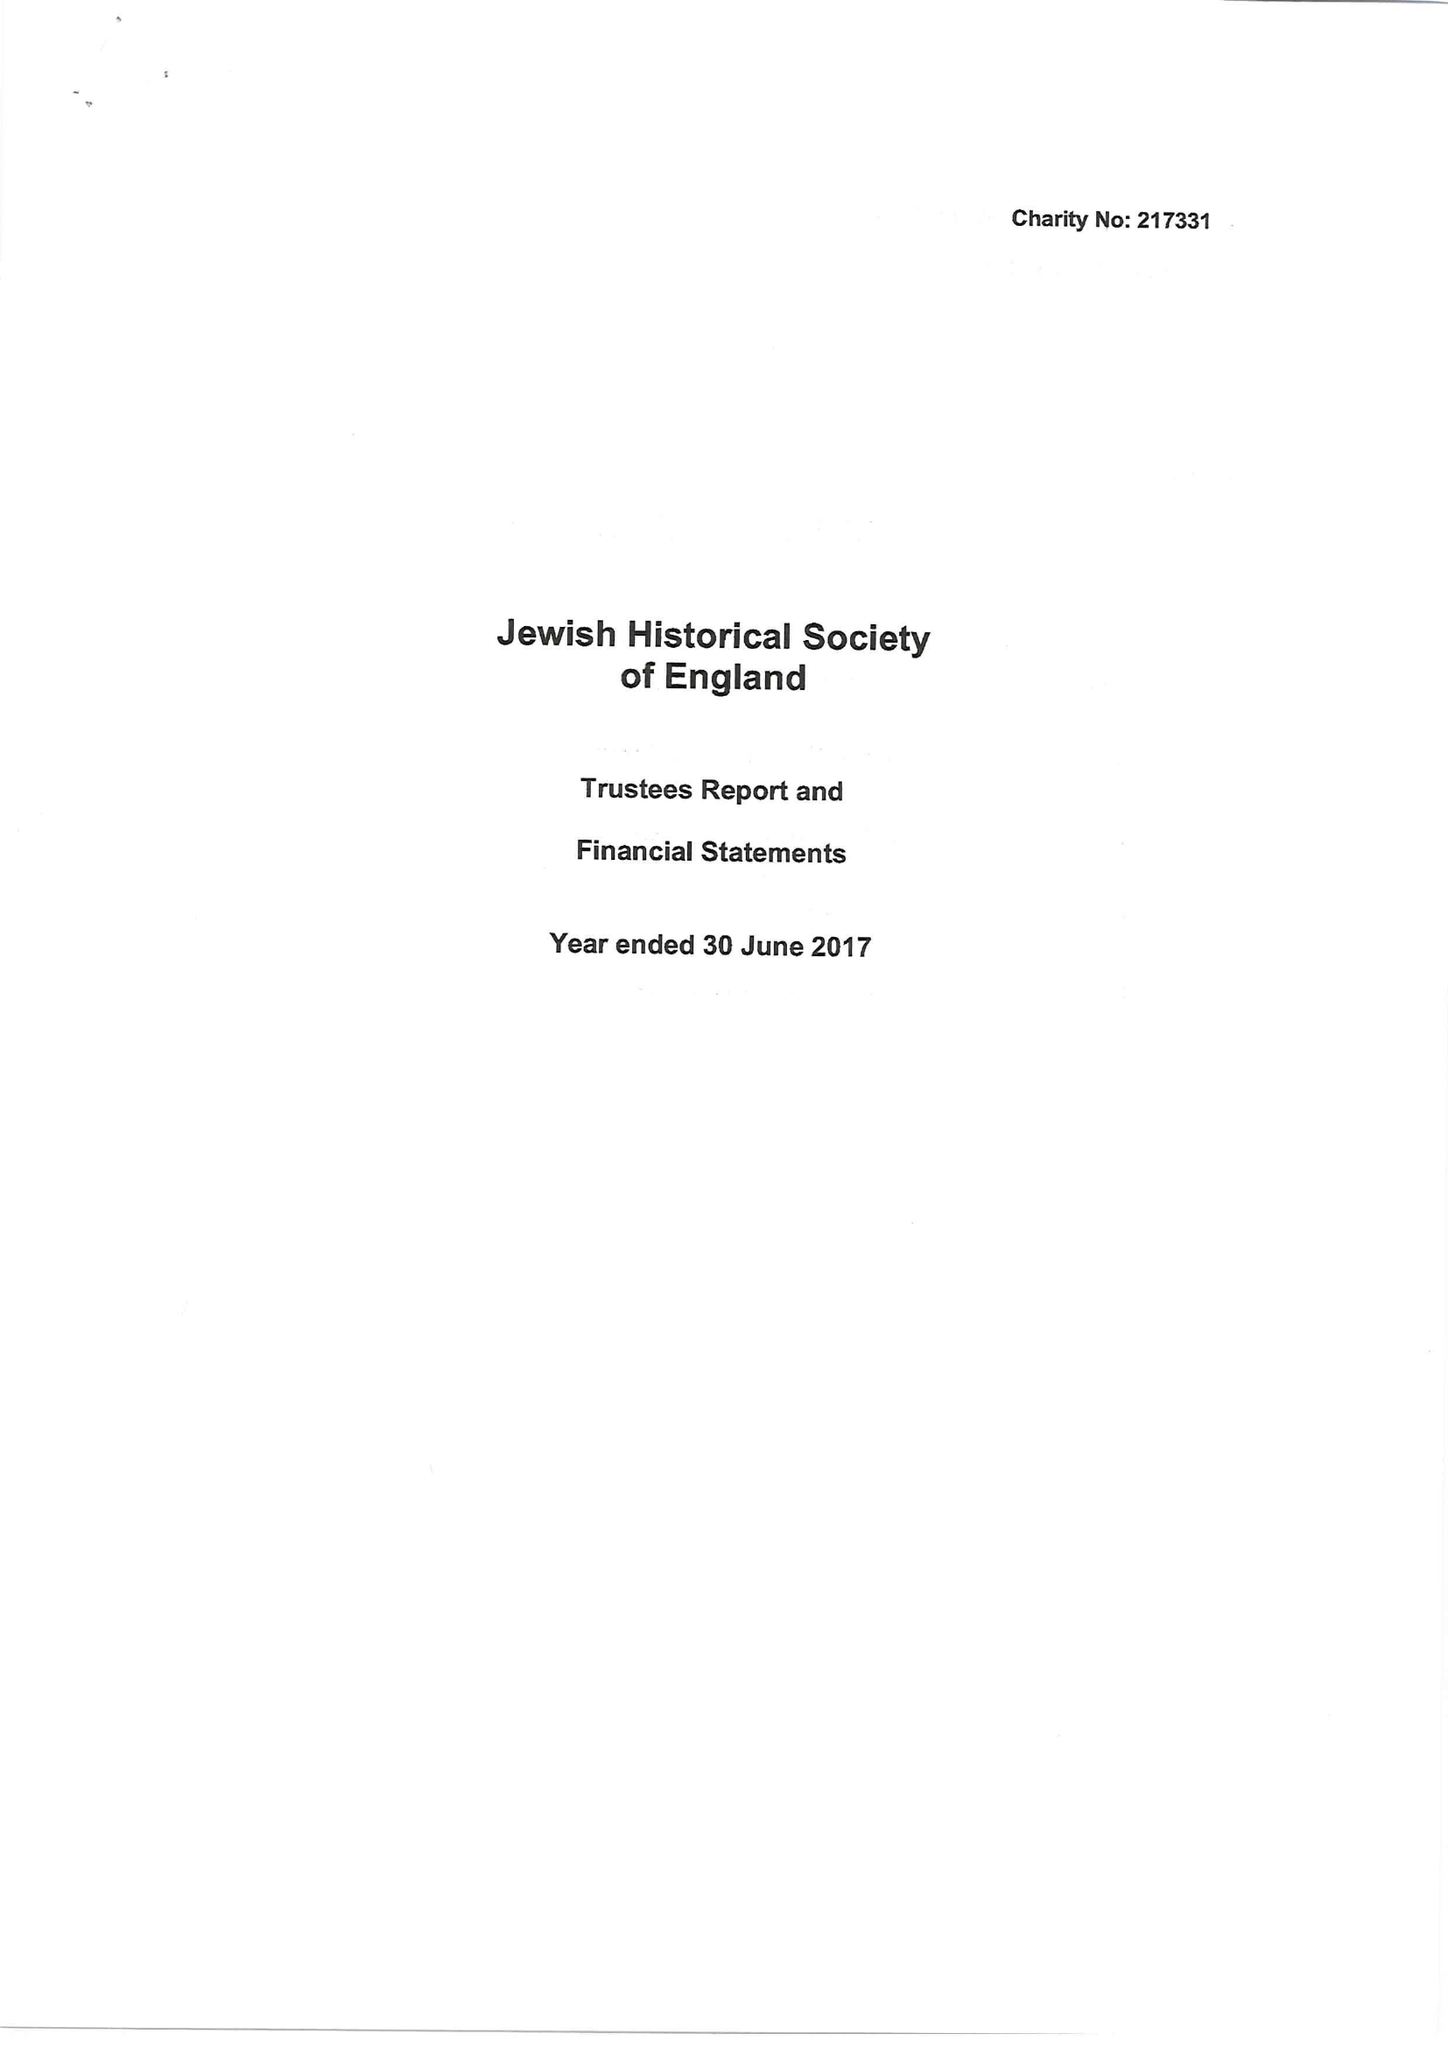What is the value for the spending_annually_in_british_pounds?
Answer the question using a single word or phrase. 25507.00 